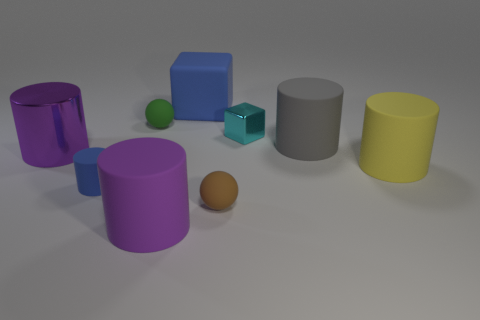Subtract all blue cubes. How many purple cylinders are left? 2 Subtract all big yellow rubber cylinders. How many cylinders are left? 4 Add 1 gray cylinders. How many objects exist? 10 Subtract all cubes. How many objects are left? 7 Subtract all brown balls. How many balls are left? 1 Subtract 0 gray balls. How many objects are left? 9 Subtract all yellow spheres. Subtract all purple cubes. How many spheres are left? 2 Subtract all yellow rubber cylinders. Subtract all small purple metallic cylinders. How many objects are left? 8 Add 8 tiny rubber cylinders. How many tiny rubber cylinders are left? 9 Add 9 tiny red cylinders. How many tiny red cylinders exist? 9 